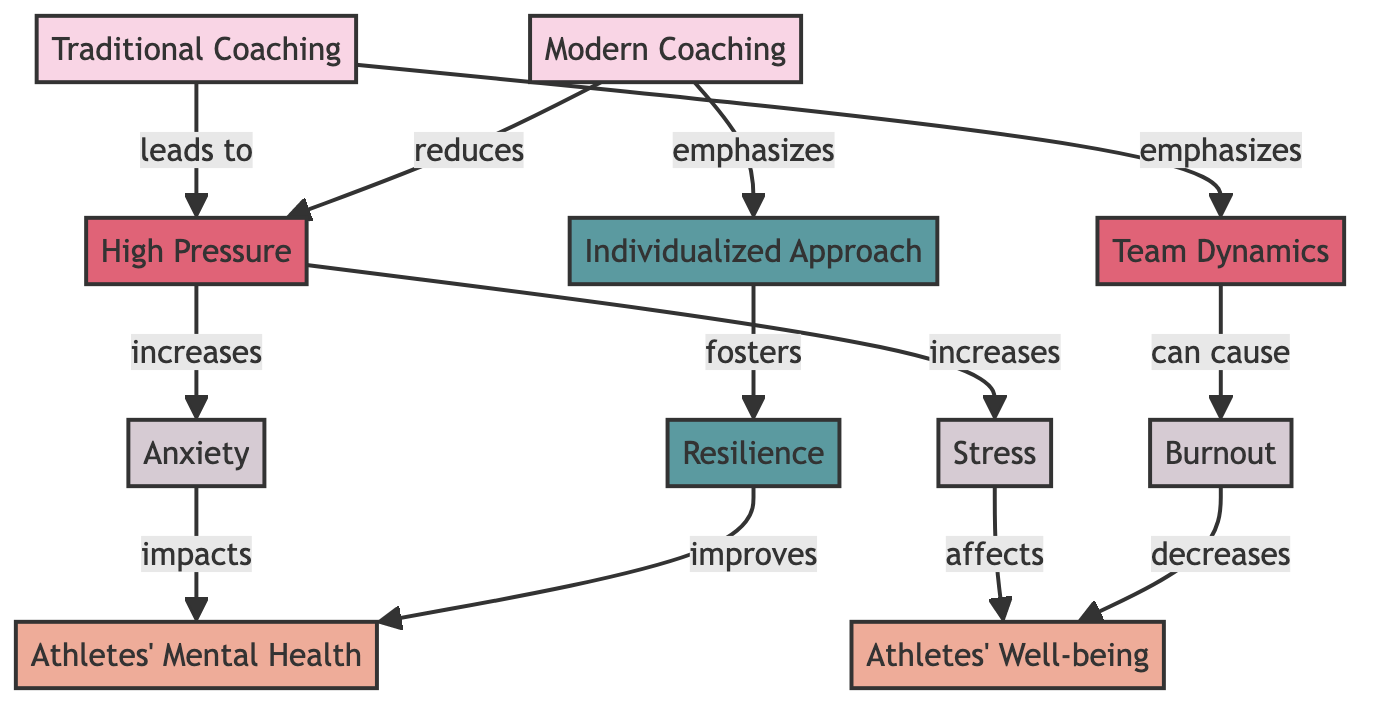What does traditional coaching lead to? The diagram shows an arrow going from "Traditional Coaching" to "High Pressure," indicating that traditional coaching leads to high pressure for athletes.
Answer: High Pressure What benefits does modern coaching provide? The diagram includes a connection from "Individualized Approach" to "Resilience," showing that modern coaching emphasizes individualized approaches which foster resilience in athletes.
Answer: Resilience What impact does high pressure have on mental health? The diagram illustrates that high pressure increases anxiety, and anxiety impacts mental health, establishing a clear connection between high pressure and its negative effects on mental health.
Answer: Anxiety Which approach emphasizes team dynamics? The flow in the diagram indicates that "Traditional Coaching" emphasizes team dynamics, making it clear that this is a characteristic of traditional coaching methodologies.
Answer: Traditional Coaching How does burnout affect well-being? The diagram shows that burnout decreases well-being, indicating that burnout has a negative impact on athletes' overall well-being as per the relationships displayed.
Answer: Decreases What factors contribute to the well-being of athletes? The diagram presents "Stress" and "Anxiety" as impacts affecting well-being, while it also shows "Resilience" as a benefit that improves well-being, creating a multi-faceted view of what influences athlete well-being.
Answer: Stress, Anxiety, Resilience Which coaching methodology reduces high pressure? The diagram indicates that modern coaching reduces high pressure, demonstrating a direct relationship between modern methodologies and pressure management in athletics.
Answer: Modern Coaching What type of coaching emphasizes an individualized approach? The diagram specifically states that modern coaching emphasizes individualized approaches, highlighting this as a key attribute of modern coaching methodologies.
Answer: Modern Coaching 